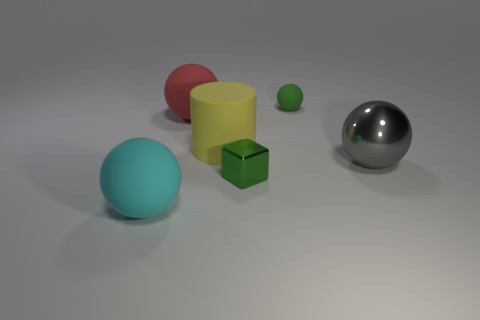Subtract all blue balls. Subtract all cyan cylinders. How many balls are left? 4 Add 3 things. How many objects exist? 9 Subtract all spheres. How many objects are left? 2 Subtract all blocks. Subtract all small spheres. How many objects are left? 4 Add 6 green matte objects. How many green matte objects are left? 7 Add 3 brown metallic cubes. How many brown metallic cubes exist? 3 Subtract 0 blue spheres. How many objects are left? 6 